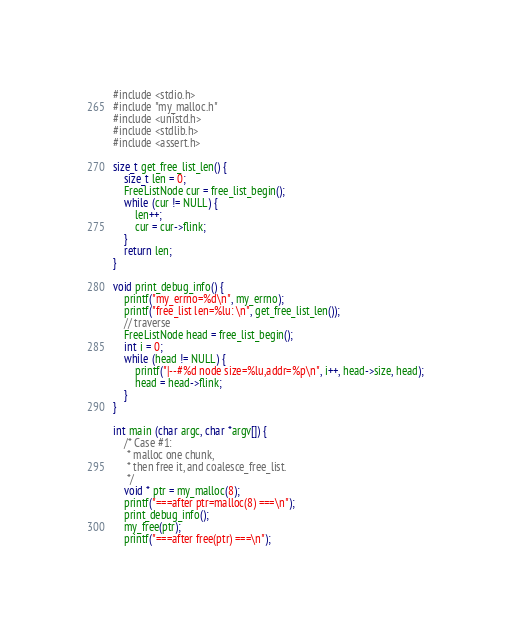<code> <loc_0><loc_0><loc_500><loc_500><_C_>#include <stdio.h>
#include "my_malloc.h"
#include <unistd.h>
#include <stdlib.h>
#include <assert.h>

size_t get_free_list_len() {
    size_t len = 0;
    FreeListNode cur = free_list_begin();
    while (cur != NULL) {
        len++;
        cur = cur->flink;
    }
    return len;
}

void print_debug_info() {
    printf("my_errno=%d\n", my_errno);
    printf("free_list len=%lu: \n", get_free_list_len());
    // traverse
    FreeListNode head = free_list_begin();
    int i = 0;
    while (head != NULL) {
        printf("|--#%d node size=%lu,addr=%p\n", i++, head->size, head);
        head = head->flink;
    }
}

int main (char argc, char *argv[]) {
    /* Case #1: 
     * malloc one chunk,
     * then free it, and coalesce_free_list.
     */
    void * ptr = my_malloc(8);
    printf("===after ptr=malloc(8) ===\n");
    print_debug_info();
    my_free(ptr);
    printf("===after free(ptr) ===\n");</code> 